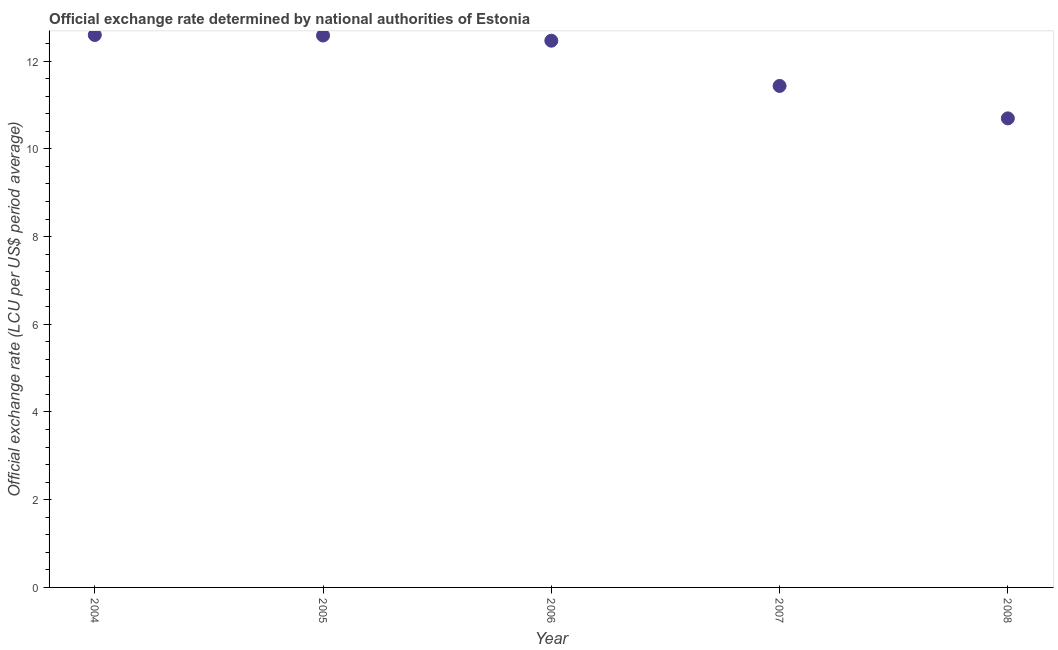What is the official exchange rate in 2007?
Provide a succinct answer. 11.43. Across all years, what is the maximum official exchange rate?
Provide a succinct answer. 12.6. Across all years, what is the minimum official exchange rate?
Provide a succinct answer. 10.69. What is the sum of the official exchange rate?
Provide a succinct answer. 59.77. What is the difference between the official exchange rate in 2006 and 2007?
Your response must be concise. 1.03. What is the average official exchange rate per year?
Offer a terse response. 11.95. What is the median official exchange rate?
Provide a short and direct response. 12.47. Do a majority of the years between 2007 and 2004 (inclusive) have official exchange rate greater than 0.8 ?
Keep it short and to the point. Yes. What is the ratio of the official exchange rate in 2004 to that in 2008?
Provide a succinct answer. 1.18. What is the difference between the highest and the second highest official exchange rate?
Your response must be concise. 0.01. Is the sum of the official exchange rate in 2004 and 2007 greater than the maximum official exchange rate across all years?
Provide a short and direct response. Yes. What is the difference between the highest and the lowest official exchange rate?
Give a very brief answer. 1.9. Does the official exchange rate monotonically increase over the years?
Give a very brief answer. No. How many dotlines are there?
Ensure brevity in your answer.  1. How many years are there in the graph?
Give a very brief answer. 5. What is the difference between two consecutive major ticks on the Y-axis?
Make the answer very short. 2. Does the graph contain any zero values?
Keep it short and to the point. No. Does the graph contain grids?
Make the answer very short. No. What is the title of the graph?
Offer a terse response. Official exchange rate determined by national authorities of Estonia. What is the label or title of the X-axis?
Your answer should be very brief. Year. What is the label or title of the Y-axis?
Your response must be concise. Official exchange rate (LCU per US$ period average). What is the Official exchange rate (LCU per US$ period average) in 2004?
Provide a short and direct response. 12.6. What is the Official exchange rate (LCU per US$ period average) in 2005?
Your answer should be compact. 12.58. What is the Official exchange rate (LCU per US$ period average) in 2006?
Your answer should be very brief. 12.47. What is the Official exchange rate (LCU per US$ period average) in 2007?
Offer a terse response. 11.43. What is the Official exchange rate (LCU per US$ period average) in 2008?
Ensure brevity in your answer.  10.69. What is the difference between the Official exchange rate (LCU per US$ period average) in 2004 and 2005?
Offer a terse response. 0.01. What is the difference between the Official exchange rate (LCU per US$ period average) in 2004 and 2006?
Your response must be concise. 0.13. What is the difference between the Official exchange rate (LCU per US$ period average) in 2004 and 2007?
Offer a very short reply. 1.16. What is the difference between the Official exchange rate (LCU per US$ period average) in 2004 and 2008?
Provide a succinct answer. 1.9. What is the difference between the Official exchange rate (LCU per US$ period average) in 2005 and 2006?
Ensure brevity in your answer.  0.12. What is the difference between the Official exchange rate (LCU per US$ period average) in 2005 and 2007?
Offer a very short reply. 1.15. What is the difference between the Official exchange rate (LCU per US$ period average) in 2005 and 2008?
Offer a very short reply. 1.89. What is the difference between the Official exchange rate (LCU per US$ period average) in 2006 and 2007?
Your response must be concise. 1.03. What is the difference between the Official exchange rate (LCU per US$ period average) in 2006 and 2008?
Give a very brief answer. 1.77. What is the difference between the Official exchange rate (LCU per US$ period average) in 2007 and 2008?
Offer a terse response. 0.74. What is the ratio of the Official exchange rate (LCU per US$ period average) in 2004 to that in 2007?
Give a very brief answer. 1.1. What is the ratio of the Official exchange rate (LCU per US$ period average) in 2004 to that in 2008?
Offer a very short reply. 1.18. What is the ratio of the Official exchange rate (LCU per US$ period average) in 2005 to that in 2007?
Provide a succinct answer. 1.1. What is the ratio of the Official exchange rate (LCU per US$ period average) in 2005 to that in 2008?
Ensure brevity in your answer.  1.18. What is the ratio of the Official exchange rate (LCU per US$ period average) in 2006 to that in 2007?
Your response must be concise. 1.09. What is the ratio of the Official exchange rate (LCU per US$ period average) in 2006 to that in 2008?
Keep it short and to the point. 1.17. What is the ratio of the Official exchange rate (LCU per US$ period average) in 2007 to that in 2008?
Provide a succinct answer. 1.07. 